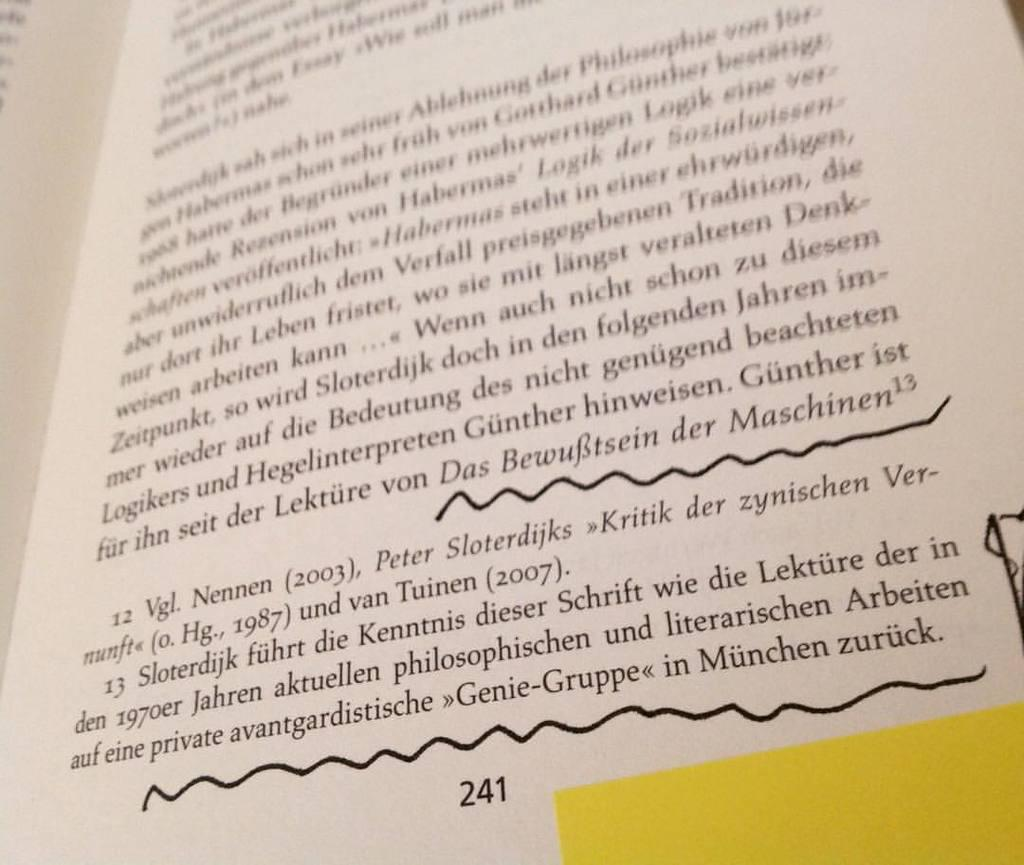<image>
Create a compact narrative representing the image presented. A book is open to page 241, which has some parts underlined. 